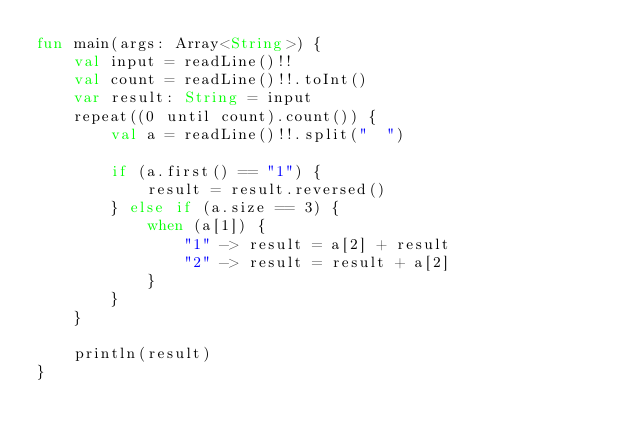<code> <loc_0><loc_0><loc_500><loc_500><_Kotlin_>fun main(args: Array<String>) {
    val input = readLine()!!
    val count = readLine()!!.toInt()
    var result: String = input
    repeat((0 until count).count()) {
        val a = readLine()!!.split("  ")

        if (a.first() == "1") {
            result = result.reversed()
        } else if (a.size == 3) {
            when (a[1]) {
                "1" -> result = a[2] + result
                "2" -> result = result + a[2]
            }
        }
    }

    println(result)
}</code> 